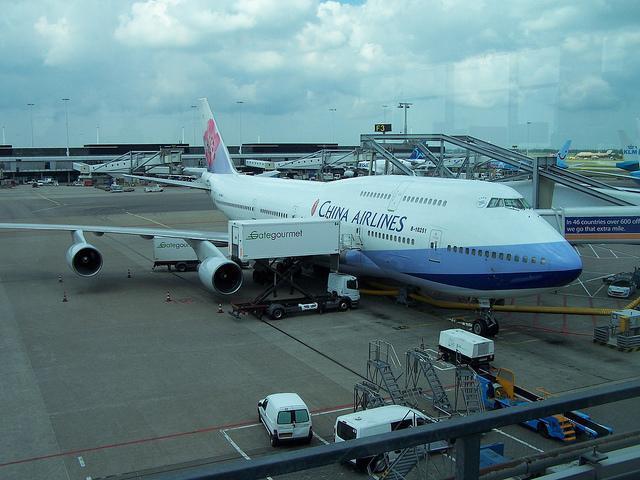How were the drivers of the cars able to park here?
Answer the question by selecting the correct answer among the 4 following choices.
Options: Firemen, airport workers, police, postal workers. Airport workers. 